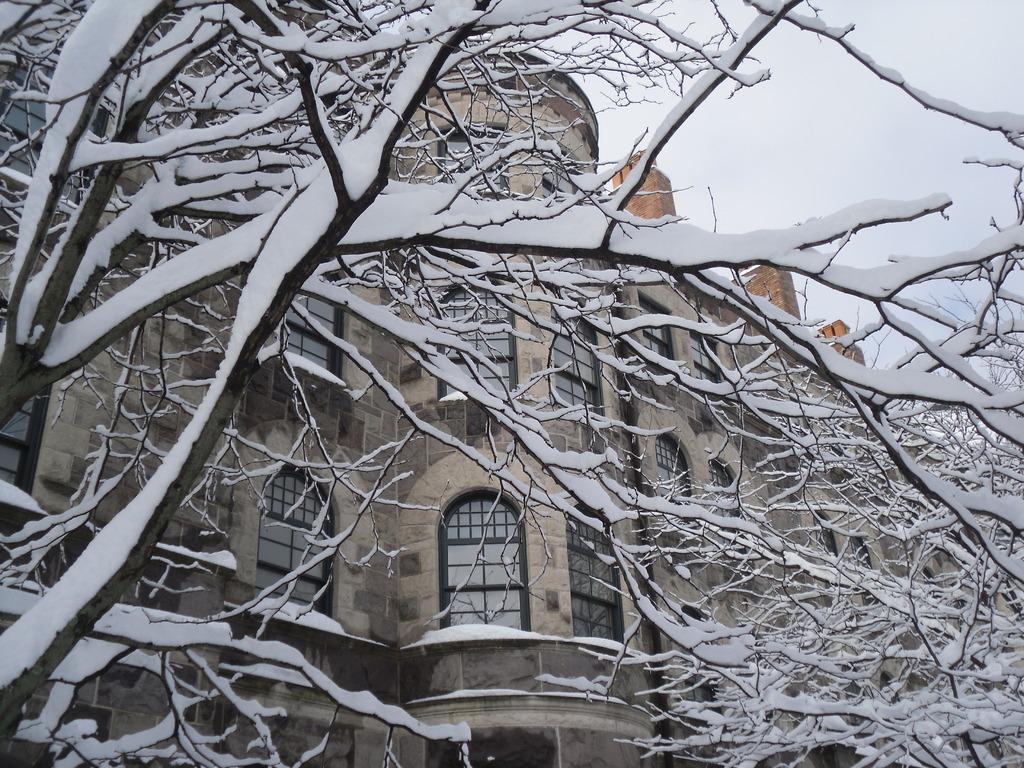Can you describe this image briefly? In this picture we can see the snow on the trees and behind the trees there is a building with windows. Behind the building there is the sky. 